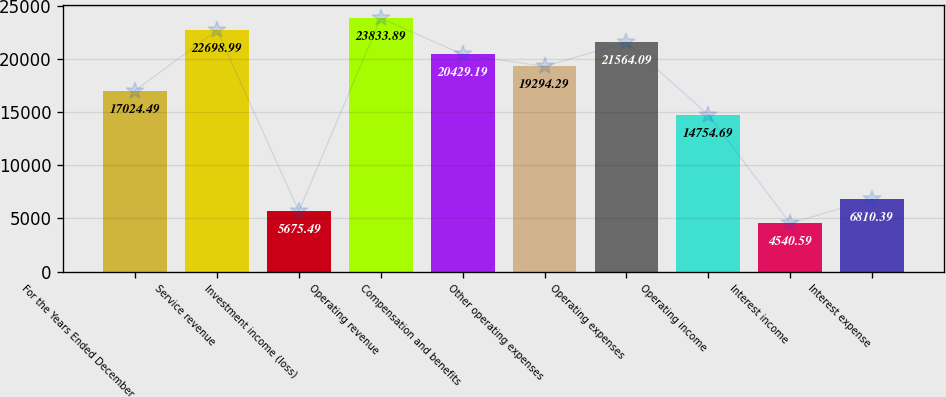Convert chart. <chart><loc_0><loc_0><loc_500><loc_500><bar_chart><fcel>For the Years Ended December<fcel>Service revenue<fcel>Investment income (loss)<fcel>Operating revenue<fcel>Compensation and benefits<fcel>Other operating expenses<fcel>Operating expenses<fcel>Operating income<fcel>Interest income<fcel>Interest expense<nl><fcel>17024.5<fcel>22699<fcel>5675.49<fcel>23833.9<fcel>20429.2<fcel>19294.3<fcel>21564.1<fcel>14754.7<fcel>4540.59<fcel>6810.39<nl></chart> 